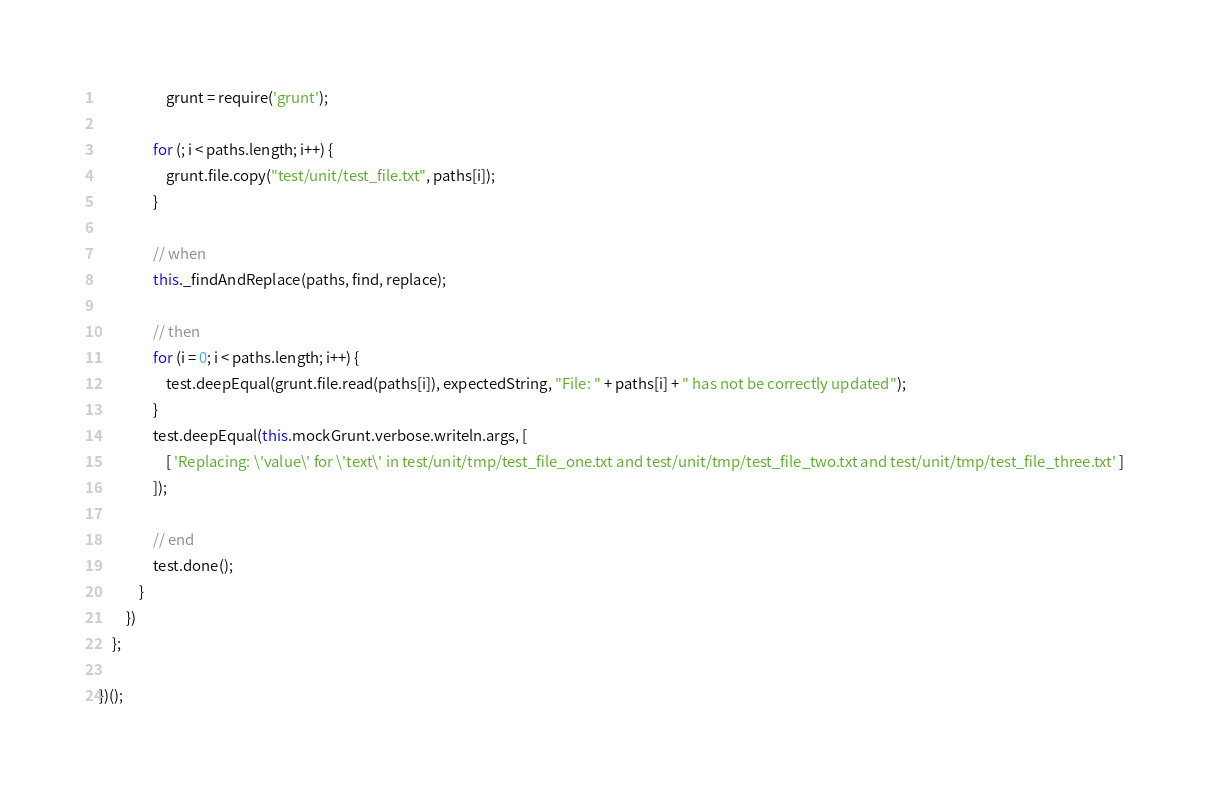<code> <loc_0><loc_0><loc_500><loc_500><_JavaScript_>                    grunt = require('grunt');

                for (; i < paths.length; i++) {
                    grunt.file.copy("test/unit/test_file.txt", paths[i]);
                }

                // when
                this._findAndReplace(paths, find, replace);

                // then
                for (i = 0; i < paths.length; i++) {
                    test.deepEqual(grunt.file.read(paths[i]), expectedString, "File: " + paths[i] + " has not be correctly updated");
                }
                test.deepEqual(this.mockGrunt.verbose.writeln.args, [
                    [ 'Replacing: \'value\' for \'text\' in test/unit/tmp/test_file_one.txt and test/unit/tmp/test_file_two.txt and test/unit/tmp/test_file_three.txt' ]
                ]);

                // end
                test.done();
            }
        })
    };

})();
</code> 